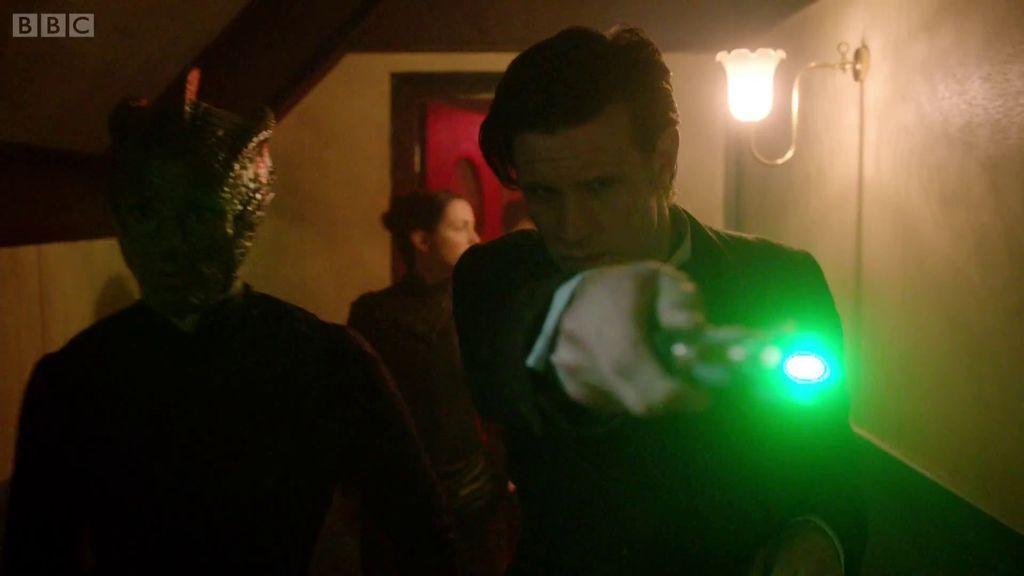Please provide a concise description of this image. On the right side of the image there is a man holding a light in his hand. And on the wall there is a lamp. Beside the man there is a person with a face mask. Behind them there is a lady. In the background there is a wall with a door. 